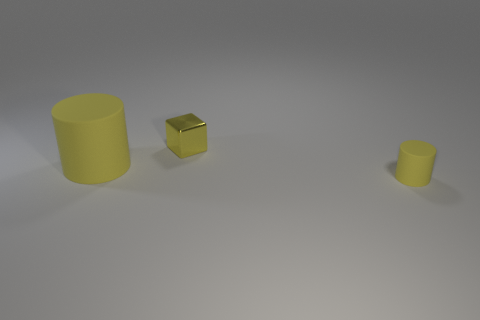There is a cube that is behind the small rubber object; does it have the same color as the matte object that is to the left of the tiny yellow rubber cylinder?
Ensure brevity in your answer.  Yes. There is a yellow thing that is to the right of the big object and in front of the yellow metallic cube; what shape is it?
Make the answer very short. Cylinder. How many objects are either tiny things that are in front of the block or cylinders left of the small yellow rubber thing?
Make the answer very short. 2. What number of other objects are the same size as the yellow block?
Provide a succinct answer. 1. What size is the yellow object that is both right of the large matte cylinder and in front of the yellow block?
Your answer should be compact. Small. How many small objects are matte things or metallic blocks?
Your answer should be very brief. 2. The matte thing behind the tiny rubber thing has what shape?
Offer a terse response. Cylinder. How many big rubber cylinders are there?
Make the answer very short. 1. Is the material of the big yellow object the same as the small yellow cylinder?
Provide a succinct answer. Yes. Are there more tiny yellow objects that are in front of the small yellow shiny block than tiny red cubes?
Keep it short and to the point. Yes. 